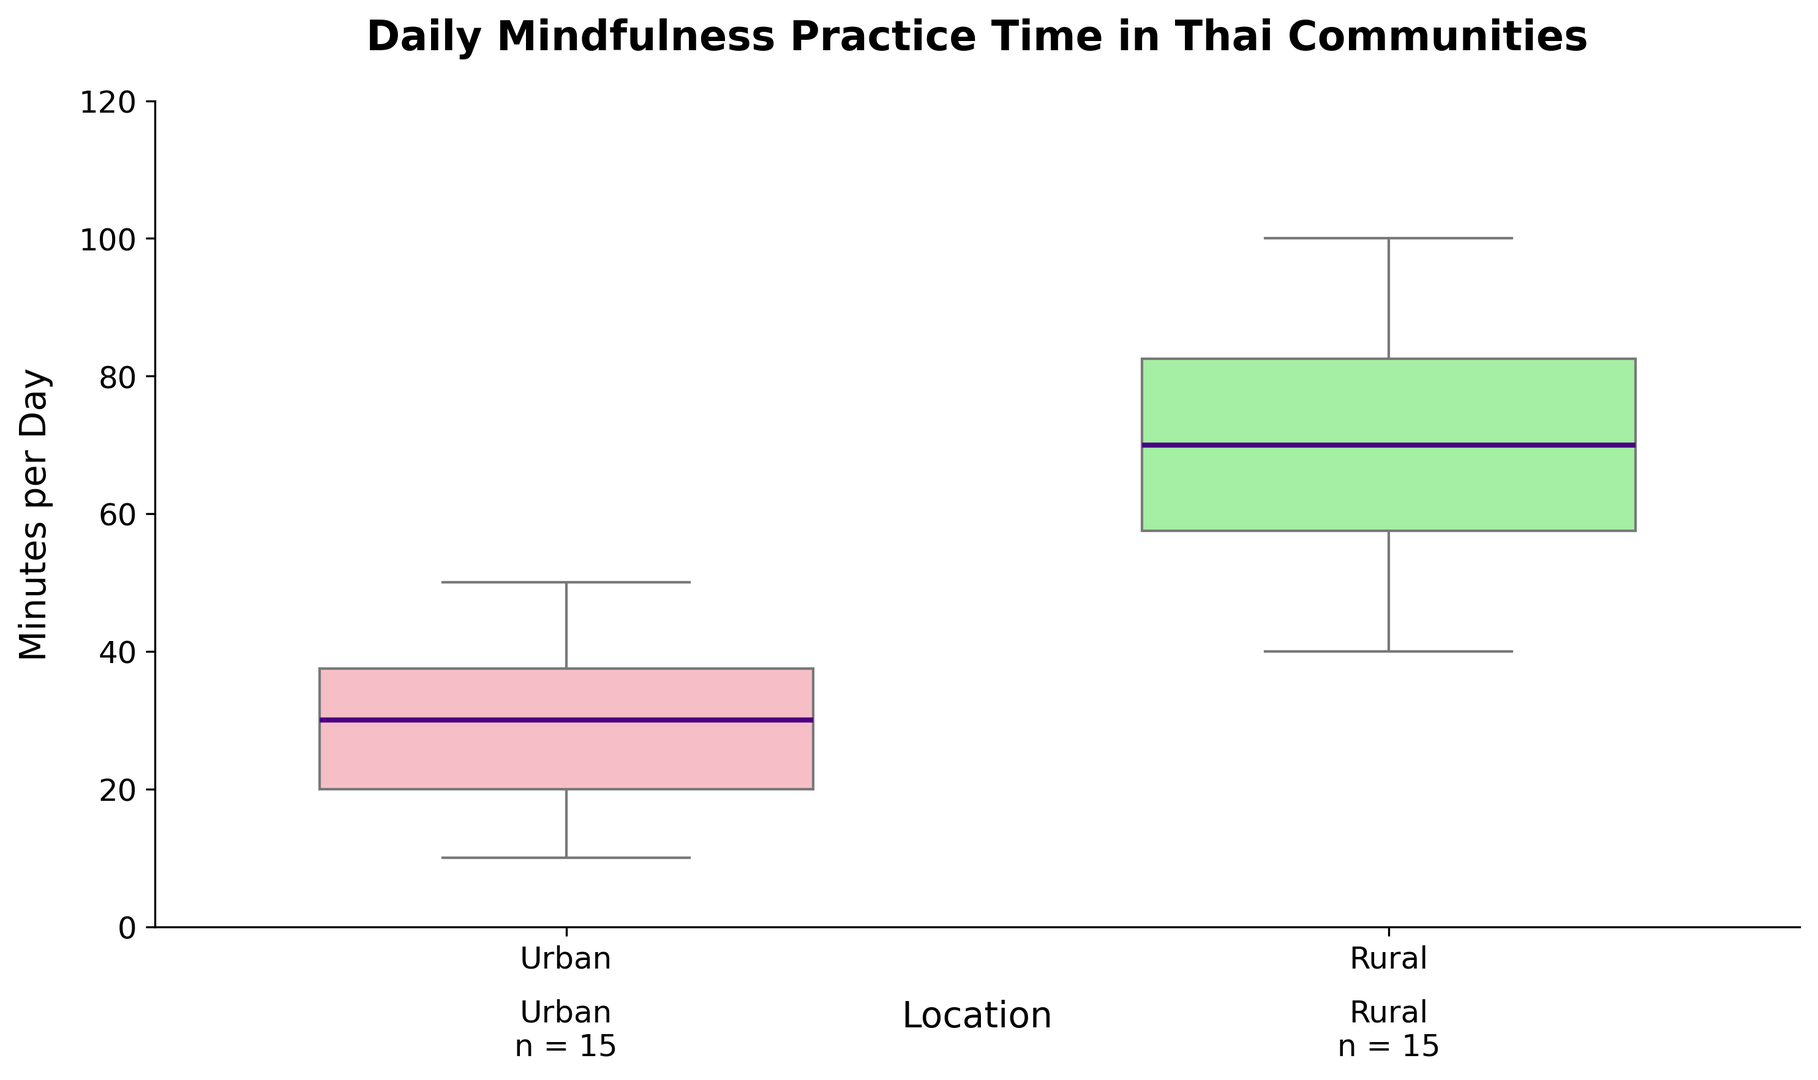Which location reported the longer median daily mindfulness practice time? The median line for the Rural box plot is higher up the y-axis compared to the Urban box plot. This indicates that the Rural group's median daily mindfulness practice time is longer.
Answer: Rural What is the range of daily mindfulness practice time in the Urban group? The range is calculated by subtracting the minimum value from the maximum value in the Urban box plot. The minimum is 10 minutes and the maximum is 50 minutes. Therefore, 50 - 10 = 40 minutes.
Answer: 40 minutes How does the interquartile range (IQR) of Urban and Rural groups compare? The IQR is the range between the first quartile (Q1) and the third quartile (Q3). The IQR for Urban appears smaller than Rural, as the box (which represents the IQR) for Urban is more compact compared to the Rural box.
Answer: Rural has a larger IQR Which location has more outliers in daily mindfulness practice time? Outliers are represented by markers outside the box plot. The Urban group has markers indicating outliers, while the Rural group does not show any.
Answer: Urban What is the difference in the 75th percentile values between the Urban and Rural groups? The 75th percentile, indicated by the top of each box, is around 40 minutes for Urban and around 85 minutes for Rural. The difference is 85 - 40 = 45 minutes.
Answer: 45 minutes How many participants are represented in each group? The number of participants is provided below each group label within the plot. Both Urban and Rural groups have their sample size annotated.
Answer: 15 in each group What is the maximum daily mindfulness practice time in the Rural group? The maximum value is the top whisker or the highest visible point for the Rural group, which is at 100 minutes.
Answer: 100 minutes What are the median daily mindfulness practice times for both Urban and Rural groups? The median is denoted by the line inside each box plot. The Urban median is around 30 minutes and the Rural median is around 65 minutes.
Answer: Urban: 30 minutes, Rural: 65 minutes 